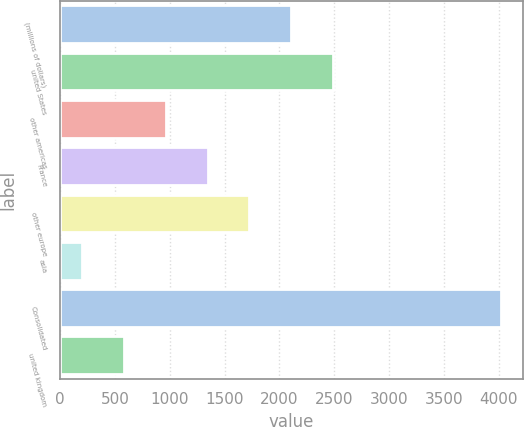Convert chart to OTSL. <chart><loc_0><loc_0><loc_500><loc_500><bar_chart><fcel>(millions of dollars)<fcel>united States<fcel>other americas<fcel>France<fcel>other europe<fcel>asia<fcel>Consolidated<fcel>united kingdom<nl><fcel>2107.95<fcel>2490.08<fcel>961.56<fcel>1343.69<fcel>1725.82<fcel>197.3<fcel>4018.6<fcel>579.43<nl></chart> 